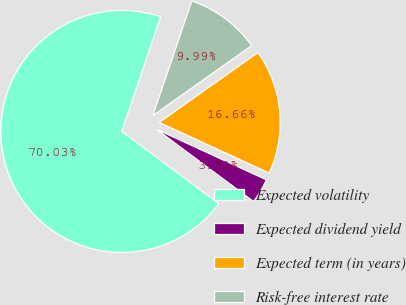Convert chart. <chart><loc_0><loc_0><loc_500><loc_500><pie_chart><fcel>Expected volatility<fcel>Expected dividend yield<fcel>Expected term (in years)<fcel>Risk-free interest rate<nl><fcel>70.02%<fcel>3.32%<fcel>16.66%<fcel>9.99%<nl></chart> 